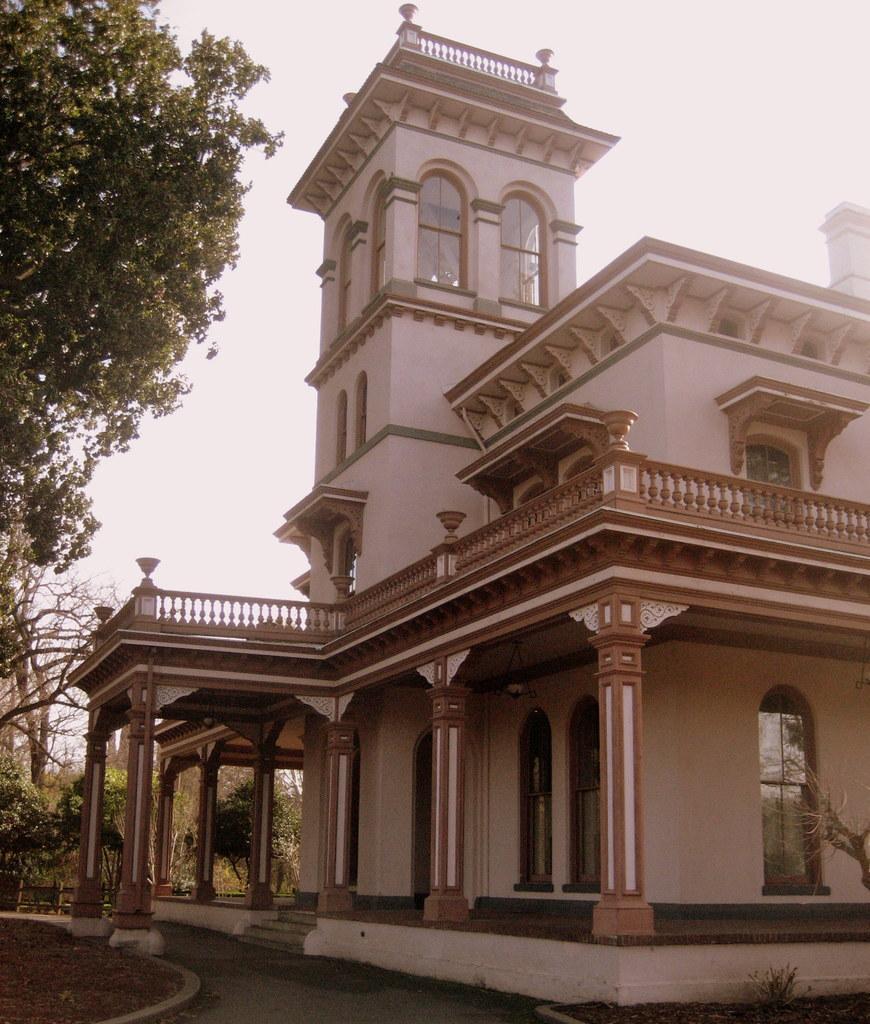Can you describe this image briefly? In this image I can see few buildings in white and brown color, trees in green color. Background the sky is in white color. 